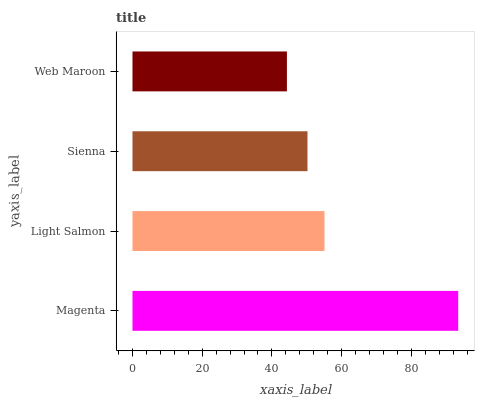Is Web Maroon the minimum?
Answer yes or no. Yes. Is Magenta the maximum?
Answer yes or no. Yes. Is Light Salmon the minimum?
Answer yes or no. No. Is Light Salmon the maximum?
Answer yes or no. No. Is Magenta greater than Light Salmon?
Answer yes or no. Yes. Is Light Salmon less than Magenta?
Answer yes or no. Yes. Is Light Salmon greater than Magenta?
Answer yes or no. No. Is Magenta less than Light Salmon?
Answer yes or no. No. Is Light Salmon the high median?
Answer yes or no. Yes. Is Sienna the low median?
Answer yes or no. Yes. Is Web Maroon the high median?
Answer yes or no. No. Is Magenta the low median?
Answer yes or no. No. 